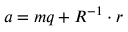<formula> <loc_0><loc_0><loc_500><loc_500>a = m q + R ^ { - 1 } \cdot r</formula> 